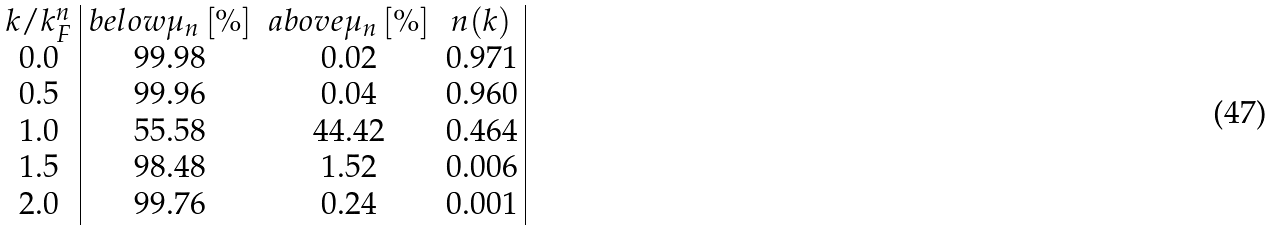<formula> <loc_0><loc_0><loc_500><loc_500>\begin{array} { c | c c c | } k / k _ { F } ^ { n } & b e l o w \mu _ { n } \, [ \% ] & a b o v e \mu _ { n } \, [ \% ] & n ( k ) \\ 0 . 0 & 9 9 . 9 8 & 0 . 0 2 & 0 . 9 7 1 \\ 0 . 5 & 9 9 . 9 6 & 0 . 0 4 & 0 . 9 6 0 \\ 1 . 0 & 5 5 . 5 8 & 4 4 . 4 2 & 0 . 4 6 4 \\ 1 . 5 & 9 8 . 4 8 & 1 . 5 2 & 0 . 0 0 6 \\ 2 . 0 & 9 9 . 7 6 & 0 . 2 4 & 0 . 0 0 1 \\ \end{array}</formula> 